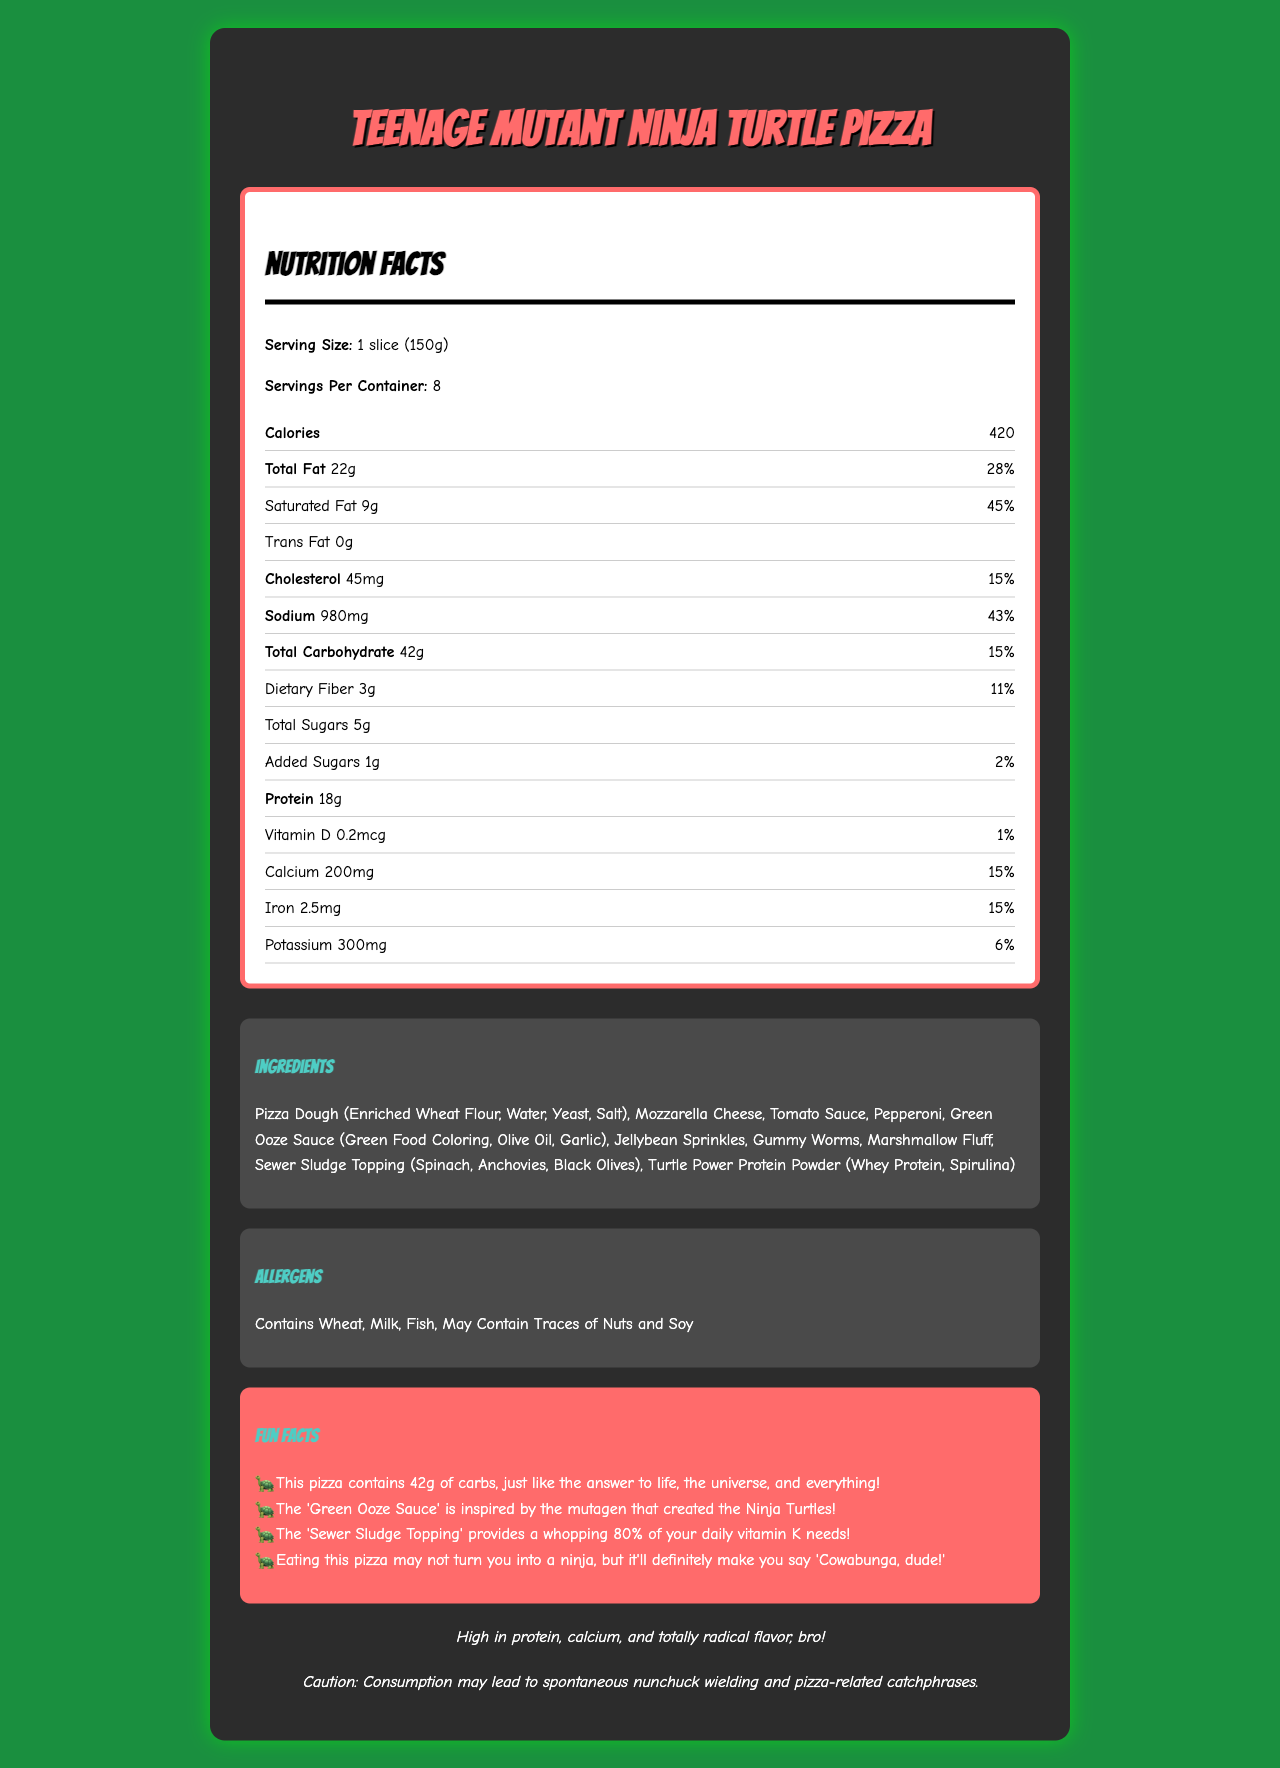who would enjoy Teenage Mutant Ninja Turtle Pizza? The pizza includes fun references like "Green Ooze Sauce" and "Sewer Sludge Topping," which show a clear connection to the Teenage Mutant Ninja Turtles theme.
Answer: Teenage Mutant Ninja Turtle fans, especially those who enjoy unconventional and fun toppings How many calories are in one slice of Teenage Mutant Ninja Turtle Pizza? The document states that each serving, which is one slice (150g), contains 420 calories.
Answer: 420 What is the serving size for Teenage Mutant Ninja Turtle Pizza? The nutrition facts specify that the serving size is 1 slice, weighing 150 grams.
Answer: 1 slice (150g) How much protein is in one slice? The nutrition label indicates that each slice contains 18 grams of protein.
Answer: 18g List three unconventional toppings found on the Teenage Mutant Ninja Turtle Pizza. These toppings are listed in the ingredients section and are unusual for a pizza.
Answer: Jellybean Sprinkles, Gummy Worms, Marshmallow Fluff What percentage of daily value for saturated fat does one slice provide? The nutrition facts state that one slice provides 9g of saturated fat, which is 45% of the daily value.
Answer: 45% What fun fact is related to the number 42? This fun fact is mentioned in the fun facts section.
Answer: The pizza contains 42 grams of carbs, just like the answer to life, the universe, and everything! Which topping is not a conventional pizza topping? A. Mozzarella Cheese B. Tomato Sauce C. Gummy Worms Gummy Worms are listed as an unconventional topping, unlike the more traditional Mozzarella Cheese and Tomato Sauce.
Answer: C What are the health warnings related to the consumption of Teenage Mutant Ninja Turtle Pizza? A. May cause allergies B. High Sodium C. Spontaneous Nunchuck Wielding D. All of the Above The document mentions potential allergens (wheat, milk, fish, nuts, and soy) and a humorous disclaimer about nunchuck wielding and pizza-related catchphrases.
Answer: D Does the pizza contain any trans fat? The nutrition facts state that the pizza contains 0g of trans fat.
Answer: No Does eating this pizza make you a ninja? The disclaimer humorously suggests that while you won't become a ninja, you may find yourself using ninja catchphrases.
Answer: No Summarize the main idea of the document. This overview covers each major section of the document's content, including nutrition details, ingredients, allergens, and fun facts, summarizing the entire document's purpose and tone.
Answer: The document provides detailed nutrition facts, fun-themed ingredients, and health information of the Teenage Mutant Ninja Turtle Pizza. It highlights its high protein content and comedic elements while cautioning about potential allergens. How many servings are in one container? The document indicates there are 8 servings per container.
Answer: 8 What is the percentage of daily value for sodium in one slice? According to the nutrition facts, one slice contains 980mg of sodium, which is 43% of the daily value.
Answer: 43% How much vitamin D is in one slice? The nutrition label states that each slice contains 0.2mcg of vitamin D.
Answer: 0.2mcg What inspired the 'Green Ooze Sauce'? This is mentioned as a fun fact in the document.
Answer: The mutagen that created the Ninja Turtles 